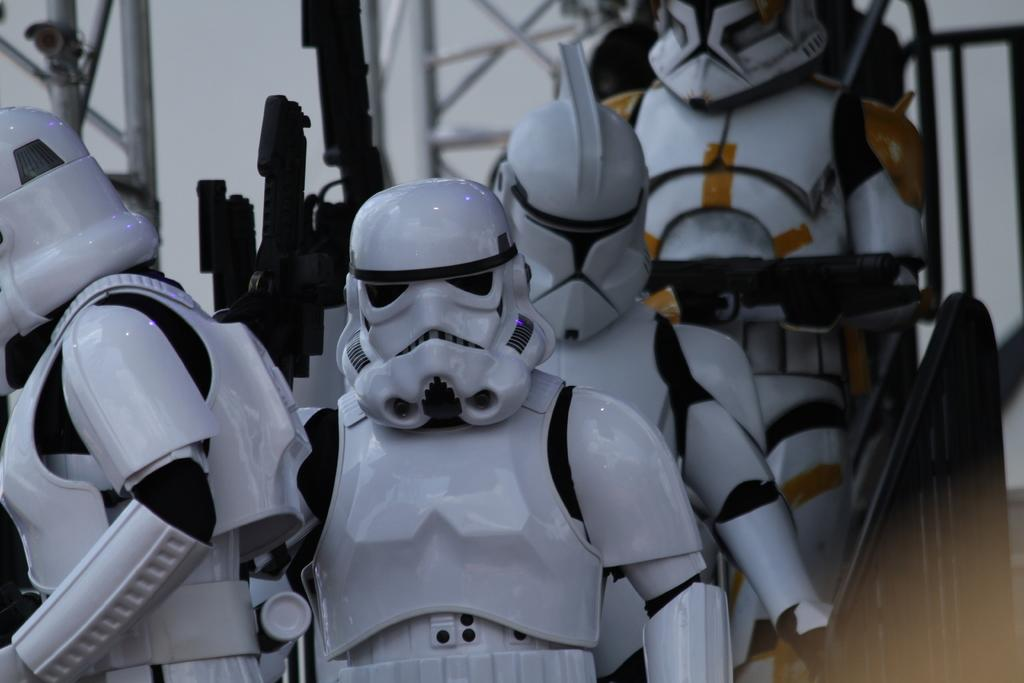What type of objects are present in the image? There are robots in the image. What can be seen near the robots? There is a railing in the image. What is visible in the background of the image? There are rods in the background of the image. What type of bear can be seen in the wilderness in the image? There is no bear or wilderness present in the image; it features robots and a railing. 